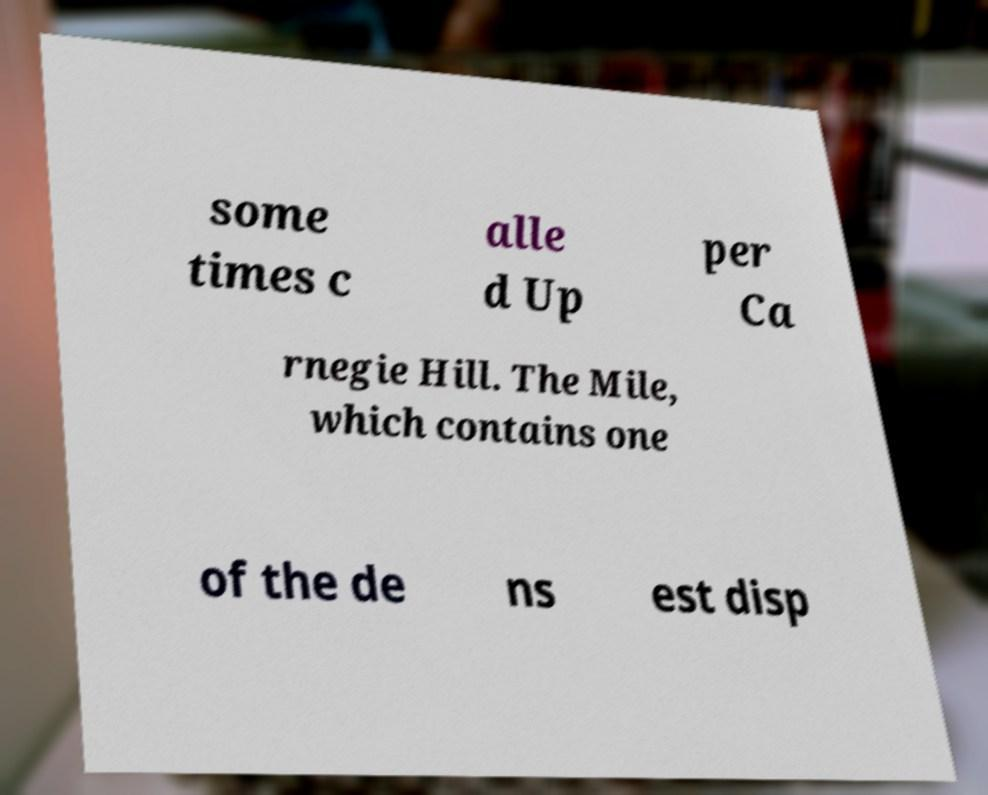What messages or text are displayed in this image? I need them in a readable, typed format. some times c alle d Up per Ca rnegie Hill. The Mile, which contains one of the de ns est disp 